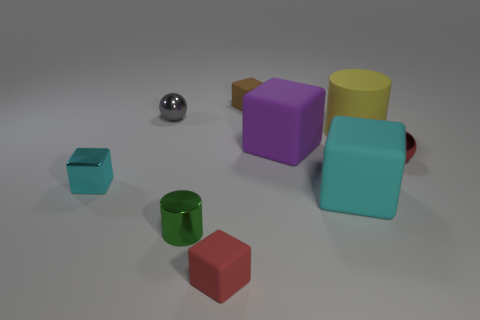Subtract all brown blocks. How many blocks are left? 4 Subtract all blue cubes. Subtract all gray cylinders. How many cubes are left? 5 Add 1 tiny purple metallic cubes. How many objects exist? 10 Subtract all cylinders. How many objects are left? 7 Subtract all shiny spheres. Subtract all small brown cubes. How many objects are left? 6 Add 5 matte cylinders. How many matte cylinders are left? 6 Add 5 large yellow rubber things. How many large yellow rubber things exist? 6 Subtract 0 cyan cylinders. How many objects are left? 9 